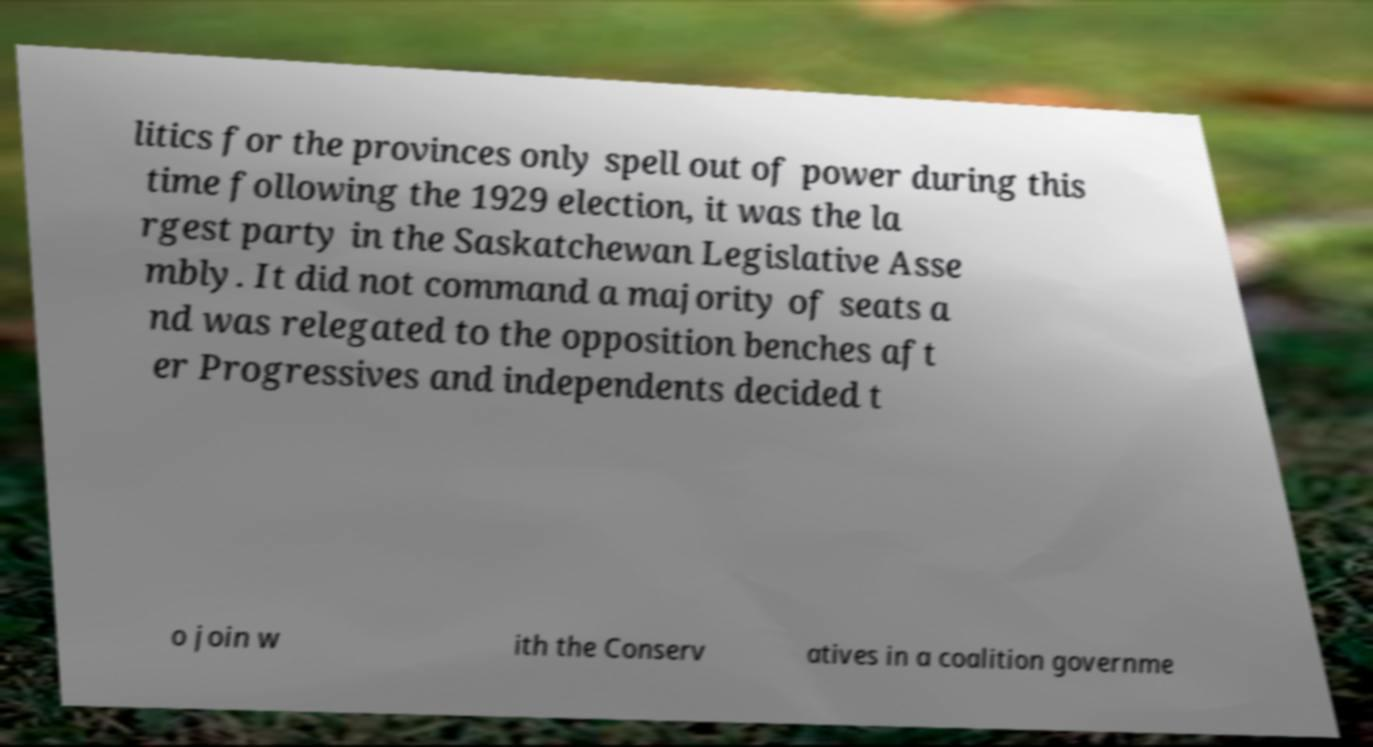There's text embedded in this image that I need extracted. Can you transcribe it verbatim? litics for the provinces only spell out of power during this time following the 1929 election, it was the la rgest party in the Saskatchewan Legislative Asse mbly. It did not command a majority of seats a nd was relegated to the opposition benches aft er Progressives and independents decided t o join w ith the Conserv atives in a coalition governme 